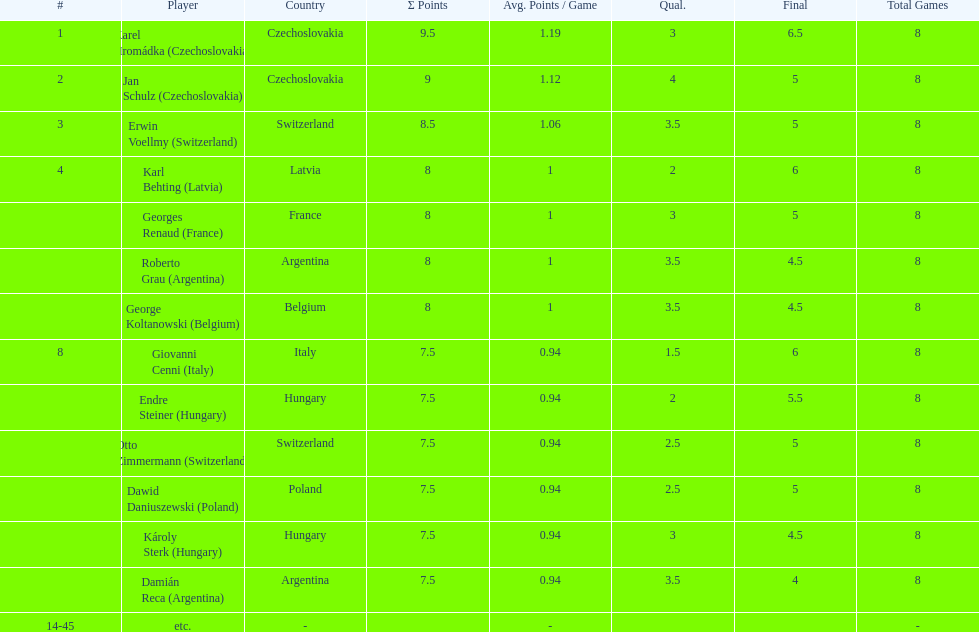In the consolation cup, how many countries were represented by multiple players? 4. 